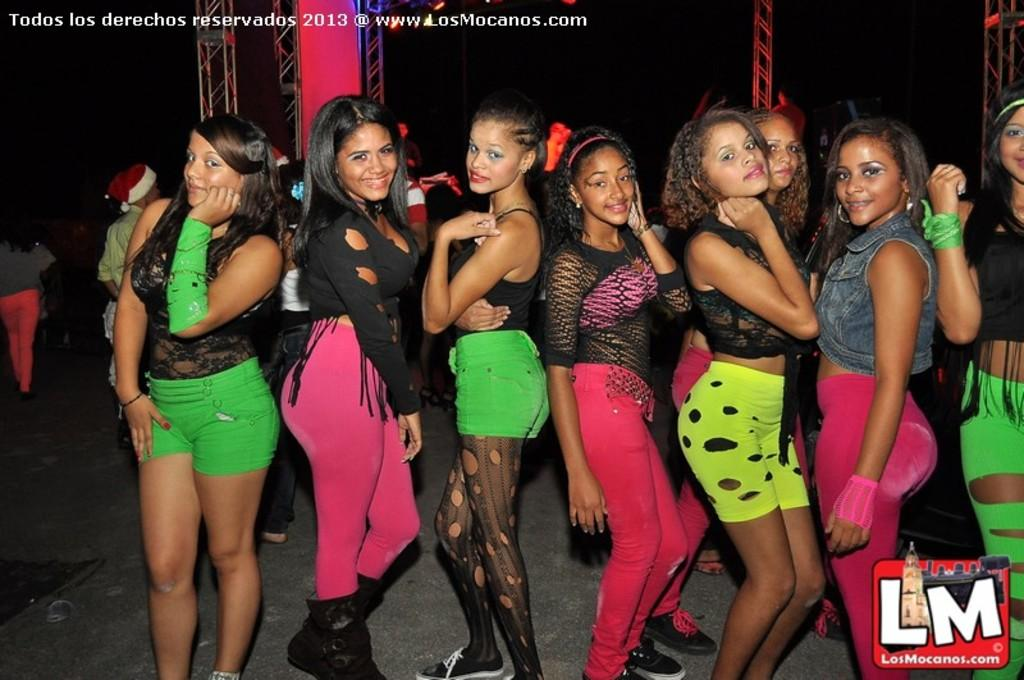Who is present in the image? There are lady persons in the image. What are the lady persons doing in the image? The lady persons are standing and posing for a photograph. What can be seen in the background of the image? There are iron rods in the background of the image. What type of sack can be seen in the image? There is no sack present in the image. How many buttons are visible on the lady persons' clothing in the image? The provided facts do not mention any buttons on the lady persons' clothing, so we cannot determine the number of buttons from the image. 